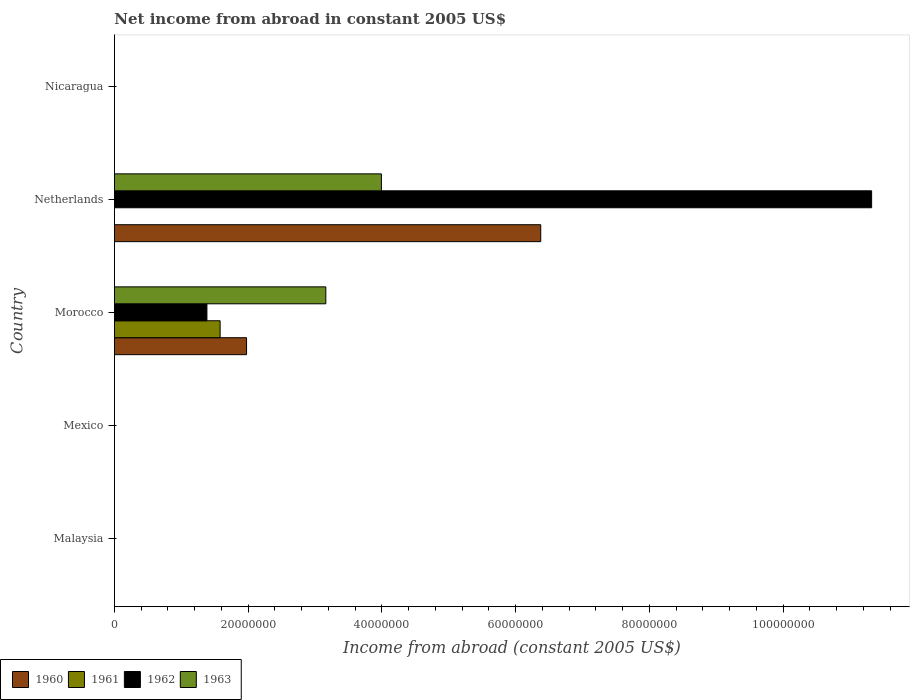Are the number of bars per tick equal to the number of legend labels?
Offer a terse response. No. Are the number of bars on each tick of the Y-axis equal?
Your answer should be very brief. No. How many bars are there on the 2nd tick from the top?
Keep it short and to the point. 3. What is the label of the 3rd group of bars from the top?
Make the answer very short. Morocco. In how many cases, is the number of bars for a given country not equal to the number of legend labels?
Ensure brevity in your answer.  4. What is the net income from abroad in 1961 in Nicaragua?
Provide a short and direct response. 0. Across all countries, what is the maximum net income from abroad in 1961?
Make the answer very short. 1.58e+07. Across all countries, what is the minimum net income from abroad in 1963?
Your answer should be compact. 0. In which country was the net income from abroad in 1961 maximum?
Make the answer very short. Morocco. What is the total net income from abroad in 1961 in the graph?
Your answer should be very brief. 1.58e+07. What is the difference between the net income from abroad in 1962 in Morocco and that in Netherlands?
Keep it short and to the point. -9.94e+07. What is the average net income from abroad in 1962 per country?
Your response must be concise. 2.54e+07. What is the difference between the net income from abroad in 1960 and net income from abroad in 1963 in Netherlands?
Ensure brevity in your answer.  2.38e+07. Is the net income from abroad in 1960 in Morocco less than that in Netherlands?
Make the answer very short. Yes. What is the difference between the highest and the lowest net income from abroad in 1963?
Make the answer very short. 3.99e+07. Is it the case that in every country, the sum of the net income from abroad in 1961 and net income from abroad in 1960 is greater than the net income from abroad in 1963?
Provide a succinct answer. No. Are all the bars in the graph horizontal?
Your response must be concise. Yes. What is the difference between two consecutive major ticks on the X-axis?
Give a very brief answer. 2.00e+07. Are the values on the major ticks of X-axis written in scientific E-notation?
Make the answer very short. No. Does the graph contain grids?
Give a very brief answer. No. Where does the legend appear in the graph?
Provide a short and direct response. Bottom left. How are the legend labels stacked?
Your answer should be compact. Horizontal. What is the title of the graph?
Offer a terse response. Net income from abroad in constant 2005 US$. What is the label or title of the X-axis?
Your response must be concise. Income from abroad (constant 2005 US$). What is the label or title of the Y-axis?
Give a very brief answer. Country. What is the Income from abroad (constant 2005 US$) in 1960 in Malaysia?
Give a very brief answer. 0. What is the Income from abroad (constant 2005 US$) in 1962 in Malaysia?
Provide a short and direct response. 0. What is the Income from abroad (constant 2005 US$) of 1960 in Mexico?
Give a very brief answer. 0. What is the Income from abroad (constant 2005 US$) of 1961 in Mexico?
Offer a very short reply. 0. What is the Income from abroad (constant 2005 US$) in 1963 in Mexico?
Give a very brief answer. 0. What is the Income from abroad (constant 2005 US$) in 1960 in Morocco?
Your answer should be compact. 1.98e+07. What is the Income from abroad (constant 2005 US$) of 1961 in Morocco?
Ensure brevity in your answer.  1.58e+07. What is the Income from abroad (constant 2005 US$) in 1962 in Morocco?
Your answer should be compact. 1.38e+07. What is the Income from abroad (constant 2005 US$) in 1963 in Morocco?
Your answer should be compact. 3.16e+07. What is the Income from abroad (constant 2005 US$) in 1960 in Netherlands?
Make the answer very short. 6.38e+07. What is the Income from abroad (constant 2005 US$) of 1961 in Netherlands?
Give a very brief answer. 0. What is the Income from abroad (constant 2005 US$) in 1962 in Netherlands?
Your answer should be compact. 1.13e+08. What is the Income from abroad (constant 2005 US$) in 1963 in Netherlands?
Ensure brevity in your answer.  3.99e+07. Across all countries, what is the maximum Income from abroad (constant 2005 US$) of 1960?
Your answer should be very brief. 6.38e+07. Across all countries, what is the maximum Income from abroad (constant 2005 US$) in 1961?
Offer a very short reply. 1.58e+07. Across all countries, what is the maximum Income from abroad (constant 2005 US$) of 1962?
Your answer should be compact. 1.13e+08. Across all countries, what is the maximum Income from abroad (constant 2005 US$) of 1963?
Make the answer very short. 3.99e+07. Across all countries, what is the minimum Income from abroad (constant 2005 US$) in 1961?
Provide a succinct answer. 0. What is the total Income from abroad (constant 2005 US$) in 1960 in the graph?
Offer a terse response. 8.35e+07. What is the total Income from abroad (constant 2005 US$) in 1961 in the graph?
Ensure brevity in your answer.  1.58e+07. What is the total Income from abroad (constant 2005 US$) in 1962 in the graph?
Ensure brevity in your answer.  1.27e+08. What is the total Income from abroad (constant 2005 US$) in 1963 in the graph?
Your answer should be compact. 7.15e+07. What is the difference between the Income from abroad (constant 2005 US$) of 1960 in Morocco and that in Netherlands?
Your response must be concise. -4.40e+07. What is the difference between the Income from abroad (constant 2005 US$) in 1962 in Morocco and that in Netherlands?
Offer a very short reply. -9.94e+07. What is the difference between the Income from abroad (constant 2005 US$) in 1963 in Morocco and that in Netherlands?
Make the answer very short. -8.31e+06. What is the difference between the Income from abroad (constant 2005 US$) of 1960 in Morocco and the Income from abroad (constant 2005 US$) of 1962 in Netherlands?
Offer a terse response. -9.35e+07. What is the difference between the Income from abroad (constant 2005 US$) in 1960 in Morocco and the Income from abroad (constant 2005 US$) in 1963 in Netherlands?
Provide a short and direct response. -2.02e+07. What is the difference between the Income from abroad (constant 2005 US$) in 1961 in Morocco and the Income from abroad (constant 2005 US$) in 1962 in Netherlands?
Your answer should be very brief. -9.74e+07. What is the difference between the Income from abroad (constant 2005 US$) in 1961 in Morocco and the Income from abroad (constant 2005 US$) in 1963 in Netherlands?
Offer a terse response. -2.41e+07. What is the difference between the Income from abroad (constant 2005 US$) of 1962 in Morocco and the Income from abroad (constant 2005 US$) of 1963 in Netherlands?
Ensure brevity in your answer.  -2.61e+07. What is the average Income from abroad (constant 2005 US$) in 1960 per country?
Give a very brief answer. 1.67e+07. What is the average Income from abroad (constant 2005 US$) in 1961 per country?
Provide a short and direct response. 3.16e+06. What is the average Income from abroad (constant 2005 US$) in 1962 per country?
Your answer should be very brief. 2.54e+07. What is the average Income from abroad (constant 2005 US$) in 1963 per country?
Ensure brevity in your answer.  1.43e+07. What is the difference between the Income from abroad (constant 2005 US$) in 1960 and Income from abroad (constant 2005 US$) in 1961 in Morocco?
Make the answer very short. 3.95e+06. What is the difference between the Income from abroad (constant 2005 US$) of 1960 and Income from abroad (constant 2005 US$) of 1962 in Morocco?
Keep it short and to the point. 5.93e+06. What is the difference between the Income from abroad (constant 2005 US$) in 1960 and Income from abroad (constant 2005 US$) in 1963 in Morocco?
Your answer should be very brief. -1.19e+07. What is the difference between the Income from abroad (constant 2005 US$) of 1961 and Income from abroad (constant 2005 US$) of 1962 in Morocco?
Offer a very short reply. 1.98e+06. What is the difference between the Income from abroad (constant 2005 US$) in 1961 and Income from abroad (constant 2005 US$) in 1963 in Morocco?
Give a very brief answer. -1.58e+07. What is the difference between the Income from abroad (constant 2005 US$) of 1962 and Income from abroad (constant 2005 US$) of 1963 in Morocco?
Provide a short and direct response. -1.78e+07. What is the difference between the Income from abroad (constant 2005 US$) of 1960 and Income from abroad (constant 2005 US$) of 1962 in Netherlands?
Your answer should be compact. -4.95e+07. What is the difference between the Income from abroad (constant 2005 US$) in 1960 and Income from abroad (constant 2005 US$) in 1963 in Netherlands?
Offer a terse response. 2.38e+07. What is the difference between the Income from abroad (constant 2005 US$) of 1962 and Income from abroad (constant 2005 US$) of 1963 in Netherlands?
Provide a succinct answer. 7.33e+07. What is the ratio of the Income from abroad (constant 2005 US$) in 1960 in Morocco to that in Netherlands?
Make the answer very short. 0.31. What is the ratio of the Income from abroad (constant 2005 US$) in 1962 in Morocco to that in Netherlands?
Make the answer very short. 0.12. What is the ratio of the Income from abroad (constant 2005 US$) of 1963 in Morocco to that in Netherlands?
Provide a succinct answer. 0.79. What is the difference between the highest and the lowest Income from abroad (constant 2005 US$) of 1960?
Offer a very short reply. 6.38e+07. What is the difference between the highest and the lowest Income from abroad (constant 2005 US$) in 1961?
Give a very brief answer. 1.58e+07. What is the difference between the highest and the lowest Income from abroad (constant 2005 US$) in 1962?
Provide a succinct answer. 1.13e+08. What is the difference between the highest and the lowest Income from abroad (constant 2005 US$) of 1963?
Provide a short and direct response. 3.99e+07. 